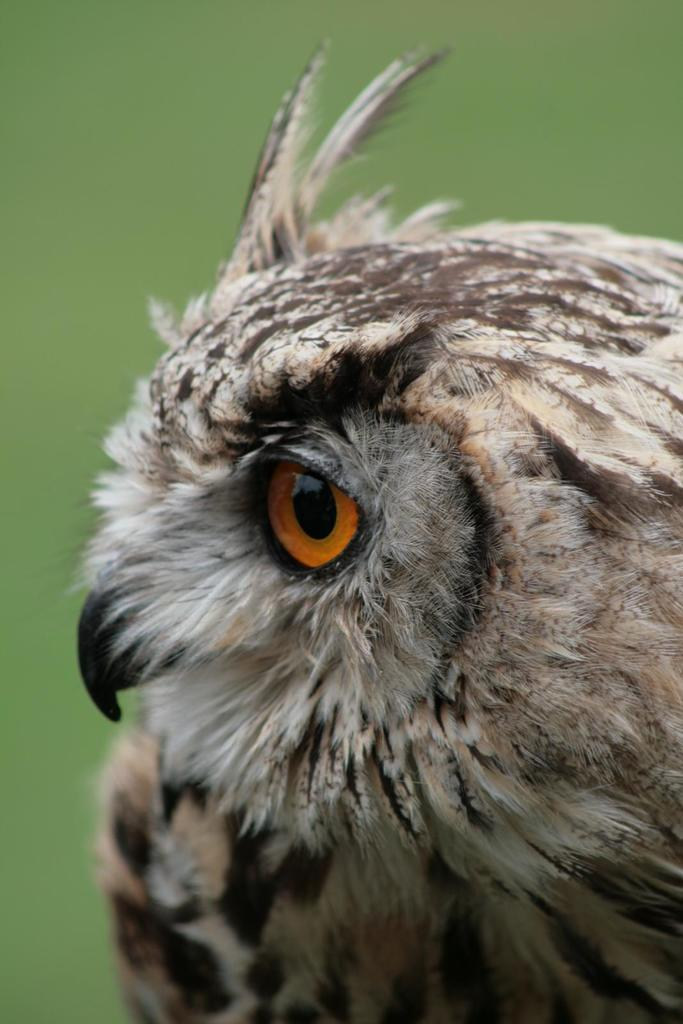What type of animal is present in the image? There is a bird in the image. What color or colors can be seen in the background of the image? The background of the image is green. What type of door can be seen in the image? There is no door present in the image; it features a bird against a green background. What kind of pipe is visible in the image? There is no pipe present in the image; it features a bird against a green background. 